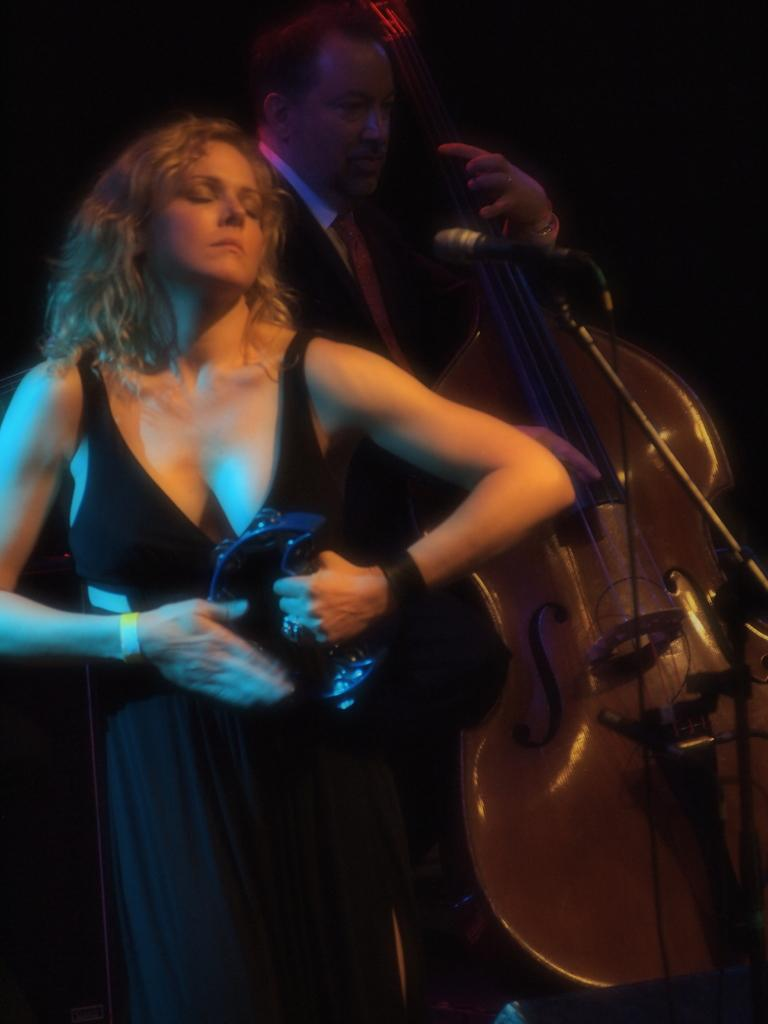Who is the main subject in the image? There is a woman in the image. What is the woman wearing? The woman is wearing a black dress. What is the woman holding in the image? The woman is holding a music instrument. Who else is present in the image? There is a man in the image. What is the man wearing? The man is wearing a suit. What is the man doing in the image? The man is playing a guitar. Who is the creator of the guitar being played in the image? The provided facts do not mention the creator of the guitar, so it cannot be determined from the image. 